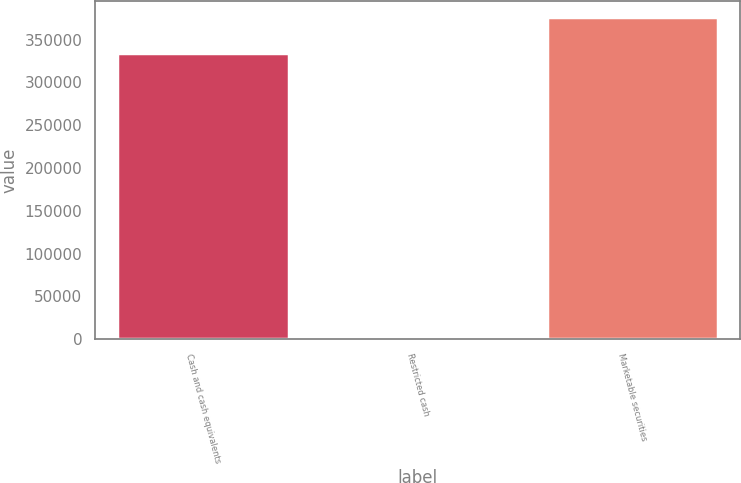Convert chart to OTSL. <chart><loc_0><loc_0><loc_500><loc_500><bar_chart><fcel>Cash and cash equivalents<fcel>Restricted cash<fcel>Marketable securities<nl><fcel>334352<fcel>1356<fcel>376723<nl></chart> 